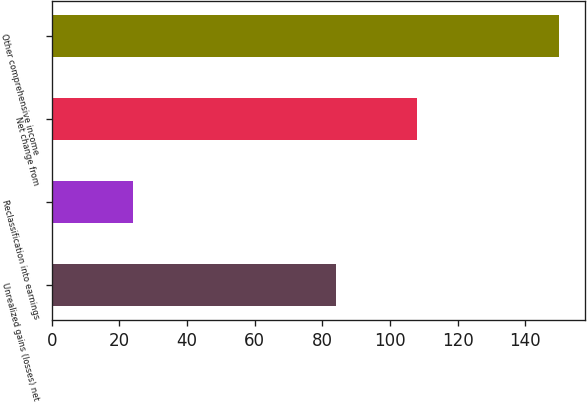Convert chart. <chart><loc_0><loc_0><loc_500><loc_500><bar_chart><fcel>Unrealized gains (losses) net<fcel>Reclassification into earnings<fcel>Net change from<fcel>Other comprehensive income<nl><fcel>84<fcel>24<fcel>108<fcel>150<nl></chart> 